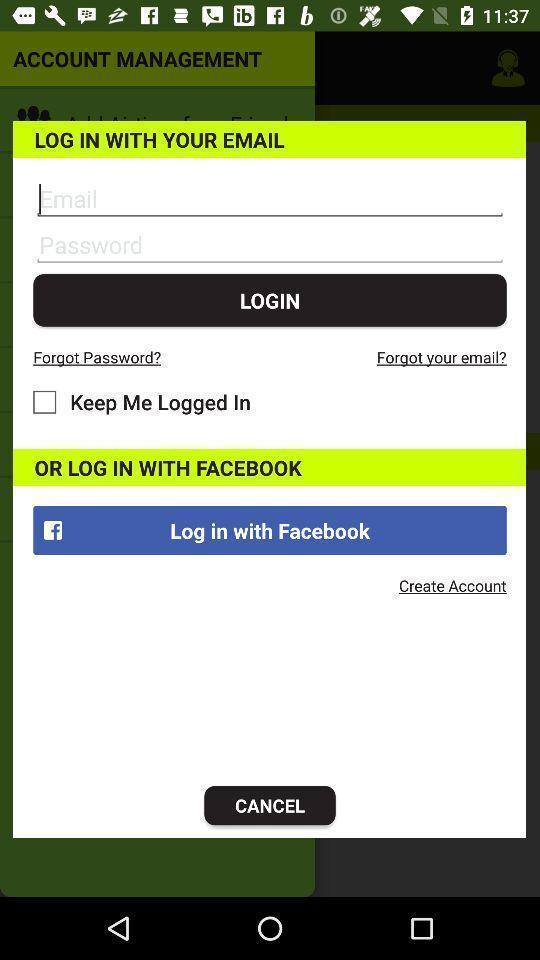Summarize the information in this screenshot. Pop up login page for an app. 